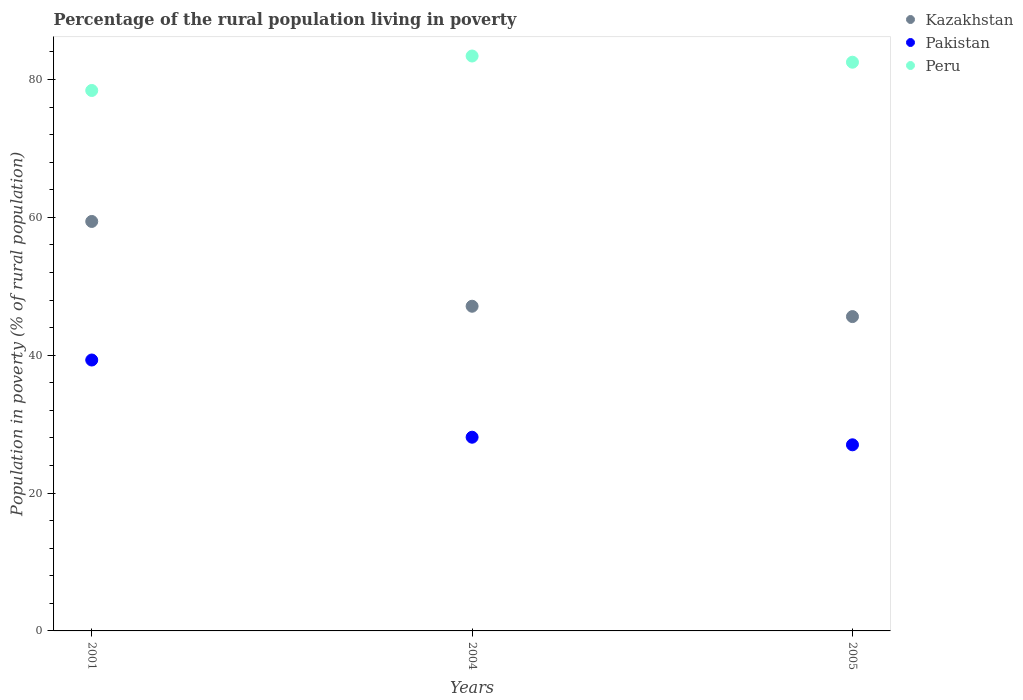How many different coloured dotlines are there?
Give a very brief answer. 3. Is the number of dotlines equal to the number of legend labels?
Offer a very short reply. Yes. What is the percentage of the rural population living in poverty in Peru in 2004?
Ensure brevity in your answer.  83.4. Across all years, what is the maximum percentage of the rural population living in poverty in Kazakhstan?
Ensure brevity in your answer.  59.4. In which year was the percentage of the rural population living in poverty in Pakistan minimum?
Make the answer very short. 2005. What is the total percentage of the rural population living in poverty in Peru in the graph?
Provide a succinct answer. 244.3. What is the difference between the percentage of the rural population living in poverty in Pakistan in 2004 and that in 2005?
Your answer should be compact. 1.1. What is the difference between the percentage of the rural population living in poverty in Peru in 2004 and the percentage of the rural population living in poverty in Pakistan in 2001?
Offer a very short reply. 44.1. What is the average percentage of the rural population living in poverty in Kazakhstan per year?
Offer a terse response. 50.7. In the year 2005, what is the difference between the percentage of the rural population living in poverty in Peru and percentage of the rural population living in poverty in Pakistan?
Your answer should be very brief. 55.5. What is the ratio of the percentage of the rural population living in poverty in Kazakhstan in 2001 to that in 2005?
Your answer should be compact. 1.3. Is the percentage of the rural population living in poverty in Peru in 2001 less than that in 2005?
Your answer should be very brief. Yes. What is the difference between the highest and the second highest percentage of the rural population living in poverty in Peru?
Keep it short and to the point. 0.9. What is the difference between the highest and the lowest percentage of the rural population living in poverty in Pakistan?
Ensure brevity in your answer.  12.3. Is the sum of the percentage of the rural population living in poverty in Peru in 2004 and 2005 greater than the maximum percentage of the rural population living in poverty in Kazakhstan across all years?
Offer a terse response. Yes. Is the percentage of the rural population living in poverty in Kazakhstan strictly less than the percentage of the rural population living in poverty in Peru over the years?
Provide a succinct answer. Yes. How many dotlines are there?
Offer a very short reply. 3. Where does the legend appear in the graph?
Give a very brief answer. Top right. How are the legend labels stacked?
Offer a very short reply. Vertical. What is the title of the graph?
Provide a succinct answer. Percentage of the rural population living in poverty. What is the label or title of the Y-axis?
Your answer should be very brief. Population in poverty (% of rural population). What is the Population in poverty (% of rural population) of Kazakhstan in 2001?
Keep it short and to the point. 59.4. What is the Population in poverty (% of rural population) of Pakistan in 2001?
Your response must be concise. 39.3. What is the Population in poverty (% of rural population) in Peru in 2001?
Provide a short and direct response. 78.4. What is the Population in poverty (% of rural population) in Kazakhstan in 2004?
Ensure brevity in your answer.  47.1. What is the Population in poverty (% of rural population) of Pakistan in 2004?
Keep it short and to the point. 28.1. What is the Population in poverty (% of rural population) of Peru in 2004?
Offer a terse response. 83.4. What is the Population in poverty (% of rural population) of Kazakhstan in 2005?
Your answer should be very brief. 45.6. What is the Population in poverty (% of rural population) in Peru in 2005?
Offer a terse response. 82.5. Across all years, what is the maximum Population in poverty (% of rural population) in Kazakhstan?
Offer a very short reply. 59.4. Across all years, what is the maximum Population in poverty (% of rural population) of Pakistan?
Your answer should be very brief. 39.3. Across all years, what is the maximum Population in poverty (% of rural population) of Peru?
Your answer should be very brief. 83.4. Across all years, what is the minimum Population in poverty (% of rural population) in Kazakhstan?
Give a very brief answer. 45.6. Across all years, what is the minimum Population in poverty (% of rural population) of Peru?
Offer a very short reply. 78.4. What is the total Population in poverty (% of rural population) in Kazakhstan in the graph?
Your response must be concise. 152.1. What is the total Population in poverty (% of rural population) of Pakistan in the graph?
Ensure brevity in your answer.  94.4. What is the total Population in poverty (% of rural population) of Peru in the graph?
Provide a short and direct response. 244.3. What is the difference between the Population in poverty (% of rural population) of Kazakhstan in 2001 and that in 2004?
Ensure brevity in your answer.  12.3. What is the difference between the Population in poverty (% of rural population) of Pakistan in 2001 and that in 2004?
Make the answer very short. 11.2. What is the difference between the Population in poverty (% of rural population) in Peru in 2001 and that in 2005?
Keep it short and to the point. -4.1. What is the difference between the Population in poverty (% of rural population) of Kazakhstan in 2001 and the Population in poverty (% of rural population) of Pakistan in 2004?
Your answer should be compact. 31.3. What is the difference between the Population in poverty (% of rural population) in Kazakhstan in 2001 and the Population in poverty (% of rural population) in Peru in 2004?
Provide a succinct answer. -24. What is the difference between the Population in poverty (% of rural population) in Pakistan in 2001 and the Population in poverty (% of rural population) in Peru in 2004?
Give a very brief answer. -44.1. What is the difference between the Population in poverty (% of rural population) of Kazakhstan in 2001 and the Population in poverty (% of rural population) of Pakistan in 2005?
Your answer should be very brief. 32.4. What is the difference between the Population in poverty (% of rural population) in Kazakhstan in 2001 and the Population in poverty (% of rural population) in Peru in 2005?
Your response must be concise. -23.1. What is the difference between the Population in poverty (% of rural population) in Pakistan in 2001 and the Population in poverty (% of rural population) in Peru in 2005?
Provide a succinct answer. -43.2. What is the difference between the Population in poverty (% of rural population) in Kazakhstan in 2004 and the Population in poverty (% of rural population) in Pakistan in 2005?
Offer a very short reply. 20.1. What is the difference between the Population in poverty (% of rural population) in Kazakhstan in 2004 and the Population in poverty (% of rural population) in Peru in 2005?
Your answer should be very brief. -35.4. What is the difference between the Population in poverty (% of rural population) in Pakistan in 2004 and the Population in poverty (% of rural population) in Peru in 2005?
Your response must be concise. -54.4. What is the average Population in poverty (% of rural population) in Kazakhstan per year?
Give a very brief answer. 50.7. What is the average Population in poverty (% of rural population) of Pakistan per year?
Your answer should be very brief. 31.47. What is the average Population in poverty (% of rural population) in Peru per year?
Keep it short and to the point. 81.43. In the year 2001, what is the difference between the Population in poverty (% of rural population) in Kazakhstan and Population in poverty (% of rural population) in Pakistan?
Offer a terse response. 20.1. In the year 2001, what is the difference between the Population in poverty (% of rural population) of Kazakhstan and Population in poverty (% of rural population) of Peru?
Make the answer very short. -19. In the year 2001, what is the difference between the Population in poverty (% of rural population) in Pakistan and Population in poverty (% of rural population) in Peru?
Give a very brief answer. -39.1. In the year 2004, what is the difference between the Population in poverty (% of rural population) of Kazakhstan and Population in poverty (% of rural population) of Pakistan?
Provide a succinct answer. 19. In the year 2004, what is the difference between the Population in poverty (% of rural population) in Kazakhstan and Population in poverty (% of rural population) in Peru?
Your answer should be very brief. -36.3. In the year 2004, what is the difference between the Population in poverty (% of rural population) of Pakistan and Population in poverty (% of rural population) of Peru?
Your answer should be very brief. -55.3. In the year 2005, what is the difference between the Population in poverty (% of rural population) in Kazakhstan and Population in poverty (% of rural population) in Pakistan?
Provide a short and direct response. 18.6. In the year 2005, what is the difference between the Population in poverty (% of rural population) of Kazakhstan and Population in poverty (% of rural population) of Peru?
Provide a short and direct response. -36.9. In the year 2005, what is the difference between the Population in poverty (% of rural population) in Pakistan and Population in poverty (% of rural population) in Peru?
Your response must be concise. -55.5. What is the ratio of the Population in poverty (% of rural population) of Kazakhstan in 2001 to that in 2004?
Provide a succinct answer. 1.26. What is the ratio of the Population in poverty (% of rural population) of Pakistan in 2001 to that in 2004?
Give a very brief answer. 1.4. What is the ratio of the Population in poverty (% of rural population) of Kazakhstan in 2001 to that in 2005?
Make the answer very short. 1.3. What is the ratio of the Population in poverty (% of rural population) of Pakistan in 2001 to that in 2005?
Provide a short and direct response. 1.46. What is the ratio of the Population in poverty (% of rural population) in Peru in 2001 to that in 2005?
Your answer should be very brief. 0.95. What is the ratio of the Population in poverty (% of rural population) of Kazakhstan in 2004 to that in 2005?
Your response must be concise. 1.03. What is the ratio of the Population in poverty (% of rural population) in Pakistan in 2004 to that in 2005?
Offer a terse response. 1.04. What is the ratio of the Population in poverty (% of rural population) of Peru in 2004 to that in 2005?
Make the answer very short. 1.01. What is the difference between the highest and the second highest Population in poverty (% of rural population) of Kazakhstan?
Your answer should be compact. 12.3. What is the difference between the highest and the second highest Population in poverty (% of rural population) in Pakistan?
Offer a very short reply. 11.2. What is the difference between the highest and the lowest Population in poverty (% of rural population) in Kazakhstan?
Offer a very short reply. 13.8. What is the difference between the highest and the lowest Population in poverty (% of rural population) in Pakistan?
Provide a short and direct response. 12.3. 